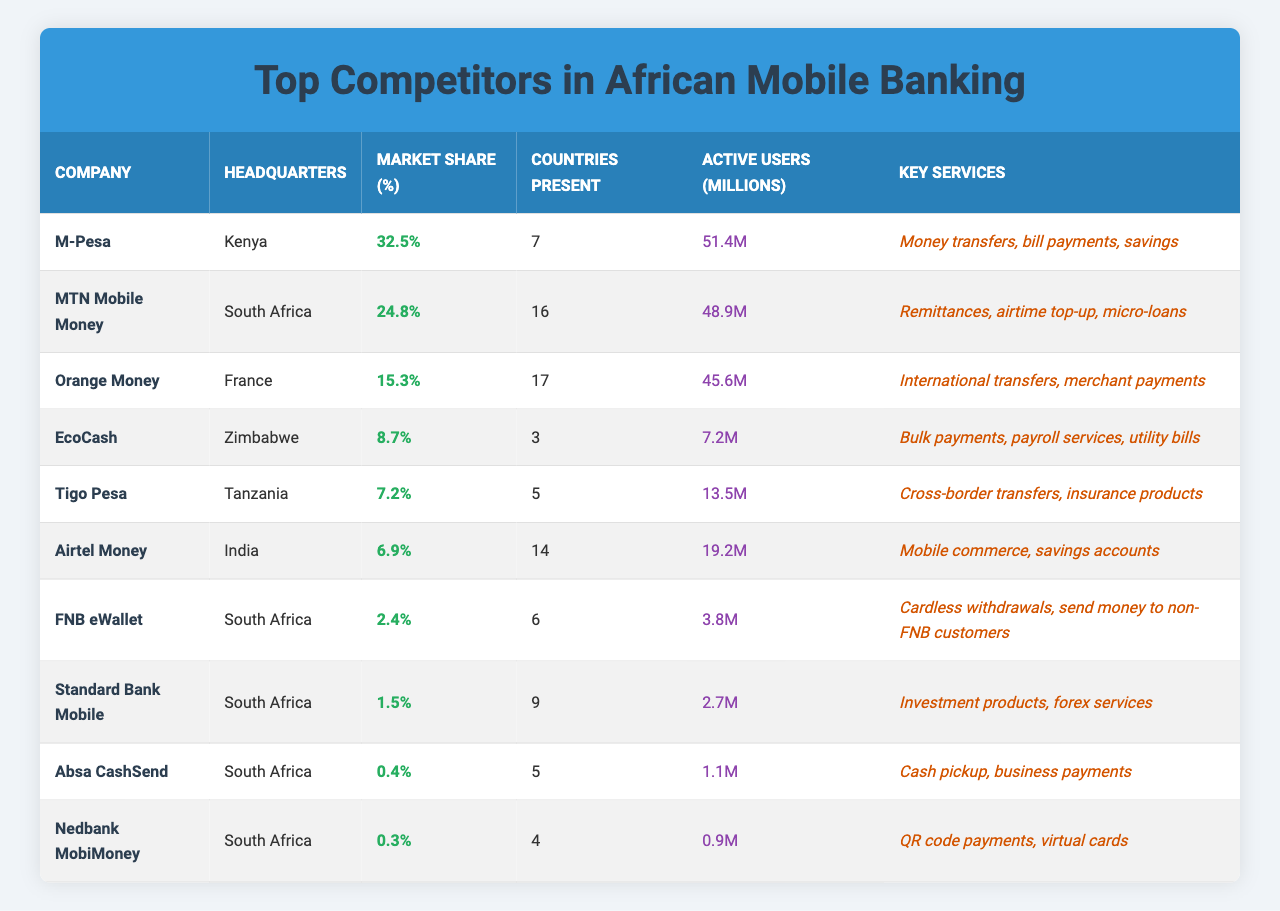What is the market share of M-Pesa? The table shows that M-Pesa has a market share of 32.5%.
Answer: 32.5% How many countries is MTN Mobile Money present in? According to the table, MTN Mobile Money is present in 16 countries.
Answer: 16 Which company has the highest number of active users? By comparing the "Active Users (Millions)" column, M-Pesa has the highest number with 51.4 million users.
Answer: M-Pesa What is the key service offered by Airtel Money? The table indicates that Airtel Money offers mobile commerce and savings accounts as key services.
Answer: Mobile commerce and savings accounts Is EcoCash present in more than 5 countries? The table states that EcoCash is present in 3 countries, which is not more than 5.
Answer: No What is the combined market share of the top three companies? The combined market share is calculated by adding the market shares of M-Pesa (32.5%), MTN Mobile Money (24.8%), and Orange Money (15.3%), totaling 72.6%.
Answer: 72.6% Which company is headquartered in France? The table shows that Orange Money is the company headquartered in France.
Answer: Orange Money How many active users does Absa CashSend have? According to the table, Absa CashSend has 1.1 million active users.
Answer: 1.1 million What is the market share difference between Tigo Pesa and Airtel Money? The market share for Tigo Pesa is 7.2%, and for Airtel Money, it is 6.9%. The difference is 7.2% - 6.9% = 0.3%.
Answer: 0.3% Which company provides payroll services? The table lists EcoCash as the company that provides payroll services among its key services.
Answer: EcoCash 